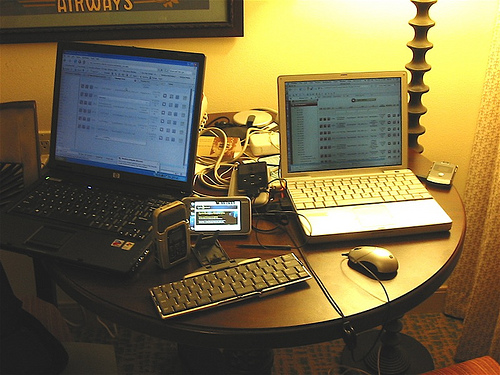Please identify all text content in this image. AIRWAYS 